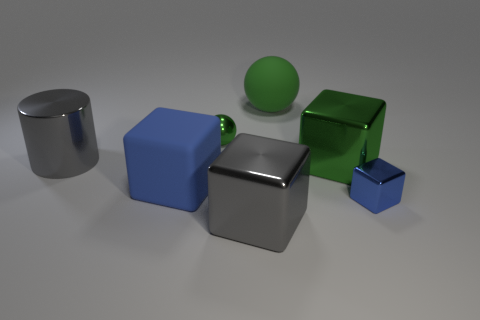What is the size of the other cube that is the same color as the tiny metal block?
Offer a terse response. Large. There is a thing that is the same color as the large metallic cylinder; what material is it?
Your answer should be compact. Metal. What is the shape of the small shiny object that is on the right side of the big rubber thing behind the big rubber thing that is to the left of the large matte sphere?
Ensure brevity in your answer.  Cube. There is a shiny cube that is on the right side of the large green block; what size is it?
Make the answer very short. Small. There is a blue matte thing that is the same size as the gray block; what shape is it?
Offer a terse response. Cube. What number of things are either large blue matte cylinders or things that are behind the big gray cylinder?
Make the answer very short. 2. There is a large gray metal thing in front of the blue block that is to the left of the small cube; what number of tiny green things are behind it?
Give a very brief answer. 1. What color is the tiny cube that is made of the same material as the large cylinder?
Provide a succinct answer. Blue. Does the green thing that is in front of the gray shiny cylinder have the same size as the large green matte sphere?
Make the answer very short. Yes. What number of objects are green spheres or big green metallic blocks?
Offer a terse response. 3. 